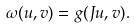<formula> <loc_0><loc_0><loc_500><loc_500>\omega ( u , v ) = g ( J u , v ) .</formula> 